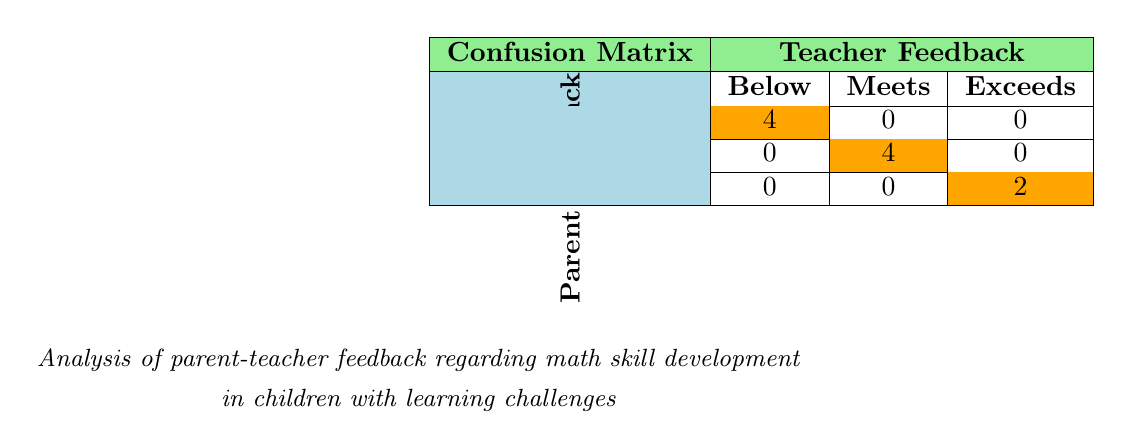What is the total number of feedback entries labeled as "Below expectations"? There are 4 entries in the "Below expectations" section of the table, indicating the total number of instances where both parents and teachers identified the student as needing improvement.
Answer: 4 How many feedback entries indicate that the student "Meets expectations"? The table shows 4 entries under the "Meets expectations" category, suggesting that this is a common assessment given by teachers in response to parent feedback.
Answer: 4 Is there any feedback labeled as "Exceeds expectations" from parents that corresponds to teachers also labeling the same student as "Below expectations"? By reviewing the table, there are no instances where feedback is categorized as "Exceeds expectations" in parent feedback while being labeled as "Below expectations" by teachers. Hence, this statement is false.
Answer: No Calculate the ratio of "Meets expectations" to "Below expectations" feedback entries. There are 4 entries for "Meets expectations" and 4 entries for "Below expectations." To find the ratio, divide these two numbers: 4/4 equals 1, meaning they are equal.
Answer: 1 What percentage of the total feedback entries are classified as "Exceeds expectations"? There are 2 entries for "Exceeds expectations", and with a total of 10 feedback entries, the percentage can be calculated as (2/10) × 100 = 20%.
Answer: 20% If a child has feedback from parents stating they "struggle with subtraction" and the teacher indicates "Below expectations," can we conclude that this child is significantly behind in math? Yes, based on the feedback from both parents and teachers, this indicates a consistent view of the child’s performance, suggesting they may require targeted support in their math skills.
Answer: Yes 